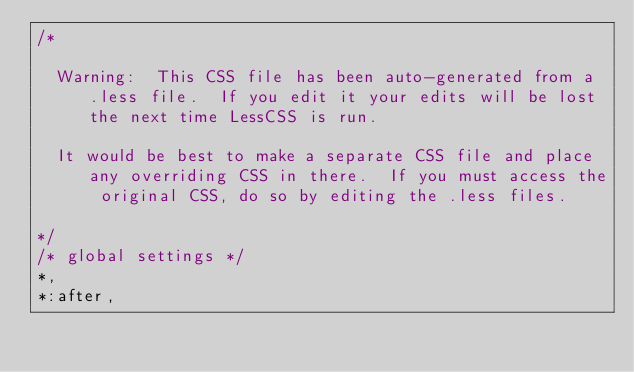Convert code to text. <code><loc_0><loc_0><loc_500><loc_500><_CSS_>/*

  Warning:  This CSS file has been auto-generated from a .less file.  If you edit it your edits will be lost the next time LessCSS is run.

  It would be best to make a separate CSS file and place any overriding CSS in there.  If you must access the original CSS, do so by editing the .less files.

*/
/* global settings */
*,
*:after,</code> 